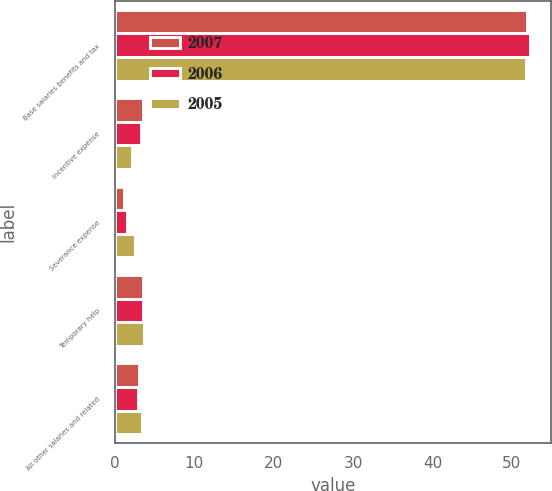<chart> <loc_0><loc_0><loc_500><loc_500><stacked_bar_chart><ecel><fcel>Base salaries benefits and tax<fcel>Incentive expense<fcel>Severance expense<fcel>Temporary help<fcel>All other salaries and related<nl><fcel>2007<fcel>51.9<fcel>3.6<fcel>1.2<fcel>3.5<fcel>3<nl><fcel>2006<fcel>52.3<fcel>3.3<fcel>1.6<fcel>3.6<fcel>2.9<nl><fcel>2005<fcel>51.8<fcel>2.2<fcel>2.6<fcel>3.7<fcel>3.4<nl></chart> 